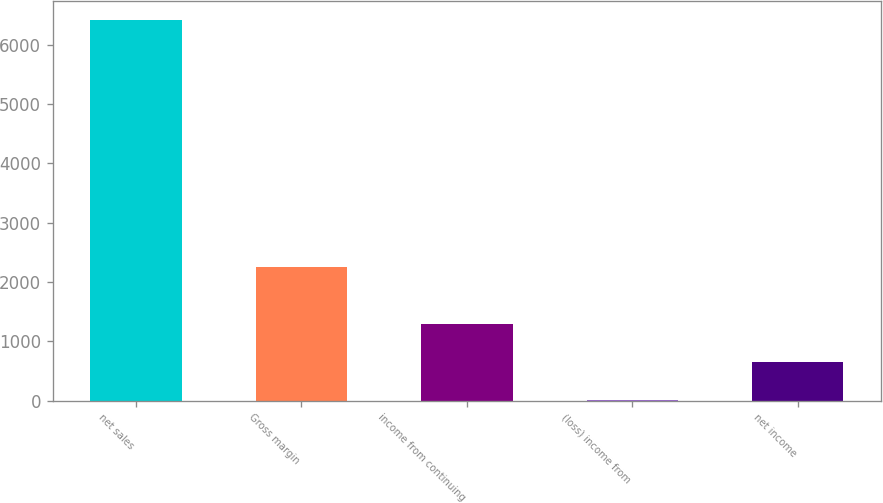Convert chart to OTSL. <chart><loc_0><loc_0><loc_500><loc_500><bar_chart><fcel>net sales<fcel>Gross margin<fcel>income from continuing<fcel>(loss) income from<fcel>net income<nl><fcel>6407.3<fcel>2257.2<fcel>1291.14<fcel>12.1<fcel>651.62<nl></chart> 